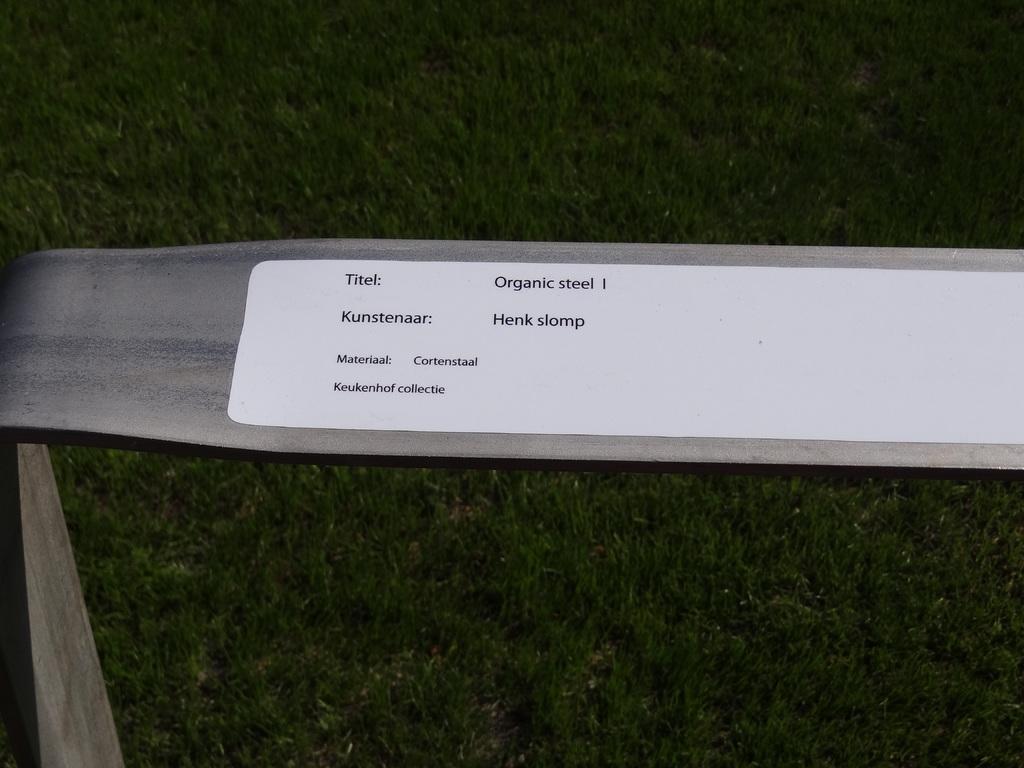Can you describe this image briefly? This image consists of a thing, which is made of steel. There is a sticker on that. 